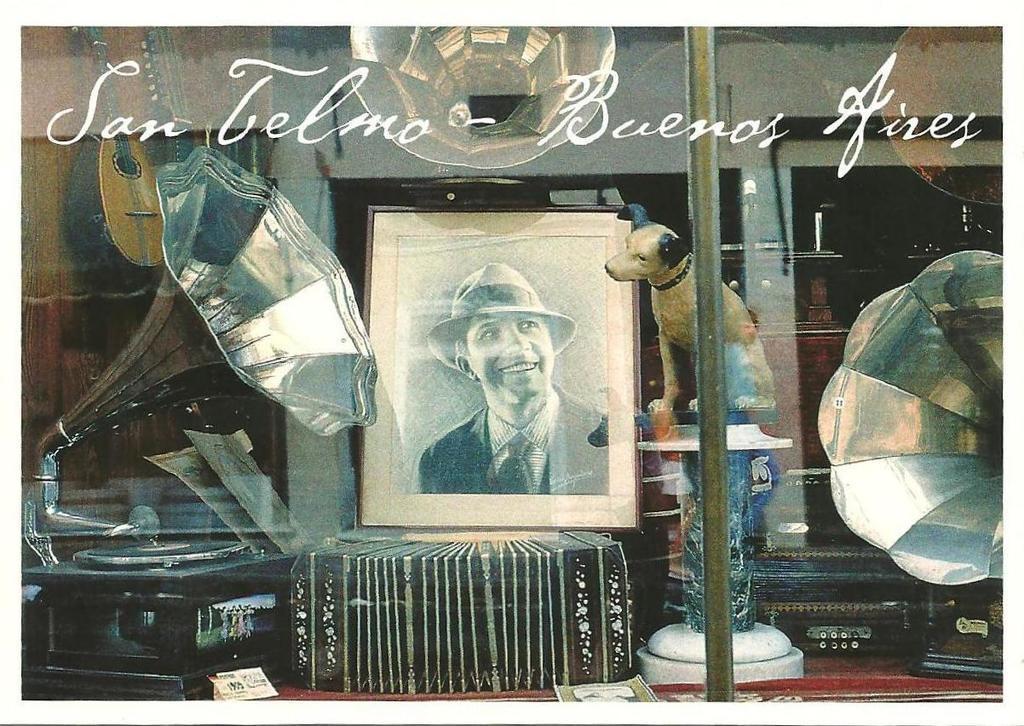Please provide a concise description of this image. In this image we can see there is a photo frame of the person behind that there is a dog sitting on the table and watching at the photo frame also there are so many musical instruments around. 